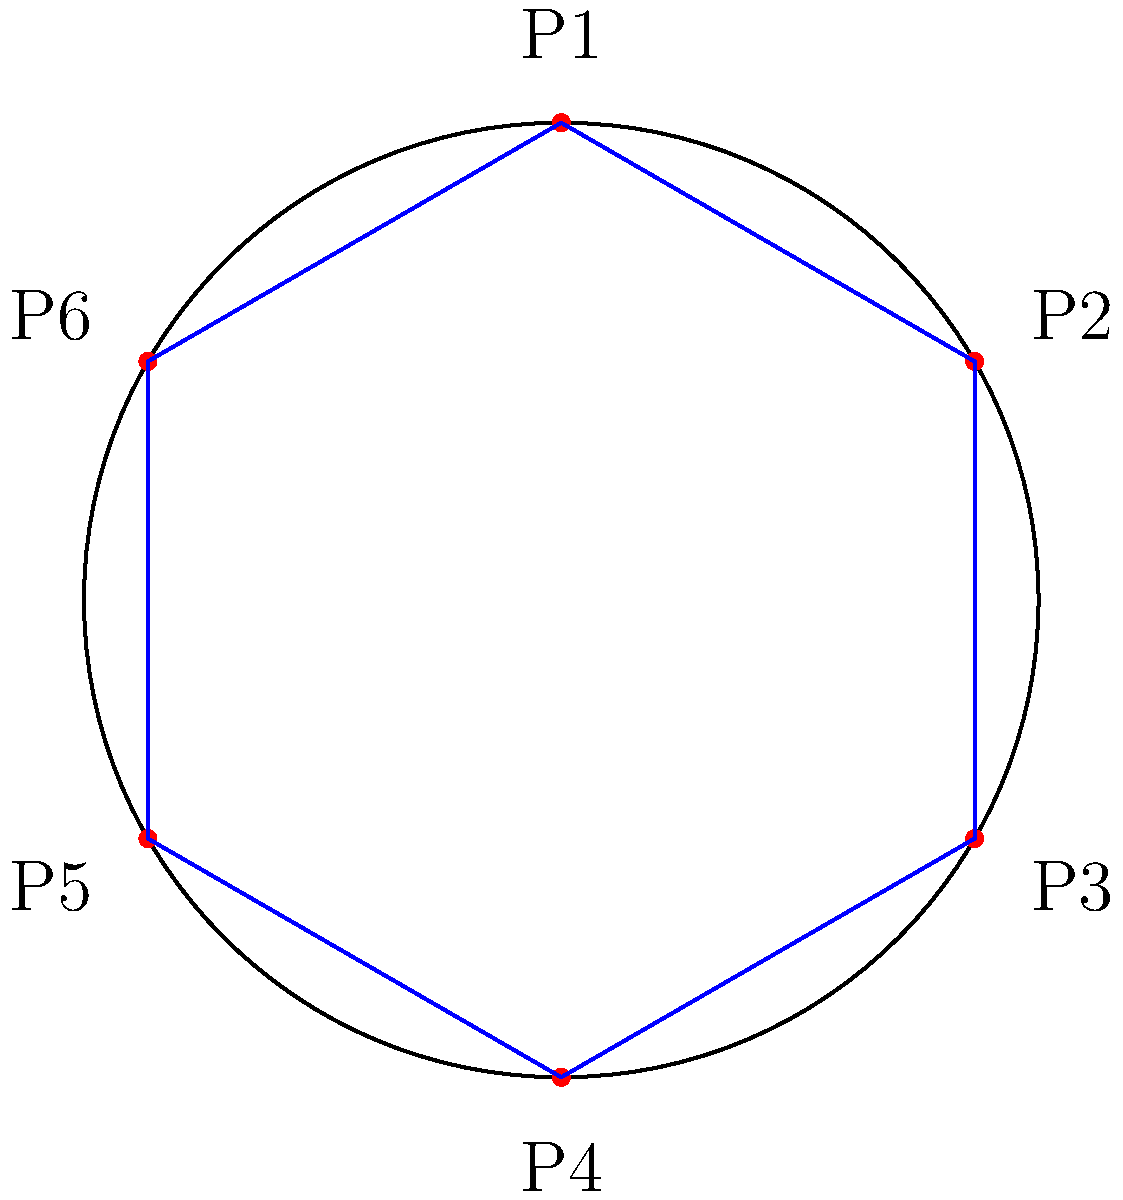In a circular arena, six players (P1 to P6) are positioned equidistantly around the edge. To maximize team coordination, you need to determine the most efficient formation. If the distance between adjacent players is $d$, what is the total distance covered by connecting all players in a hexagonal formation, expressed in terms of $d$? Let's approach this step-by-step:

1) In a regular hexagon, all sides are equal and all interior angles are 120°.

2) The players are positioned at the vertices of this hexagon.

3) The distance between adjacent players (side length of the hexagon) is given as $d$.

4) To connect all players in a hexagonal formation, we need to calculate the perimeter of the hexagon.

5) The perimeter of a regular hexagon is the sum of all its sides.

6) Since there are 6 sides, each of length $d$, the total distance covered is:

   $$\text{Total Distance} = 6d$$

7) This formation ensures that each player is connected to their two nearest neighbors, creating an efficient circular defensive or offensive structure.

8) The hexagonal formation also allows for quick rotations and position switches, which is crucial in team-based combat scenarios in games like Lineage II.
Answer: $6d$ 